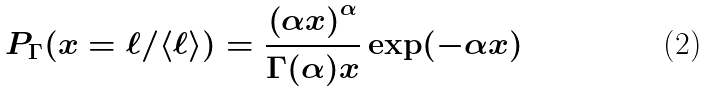<formula> <loc_0><loc_0><loc_500><loc_500>P _ { \Gamma } ( x = \ell / \langle \ell \rangle ) = \frac { \left ( \alpha x \right ) ^ { \alpha } } { \Gamma ( \alpha ) x } \exp ( - \alpha x )</formula> 